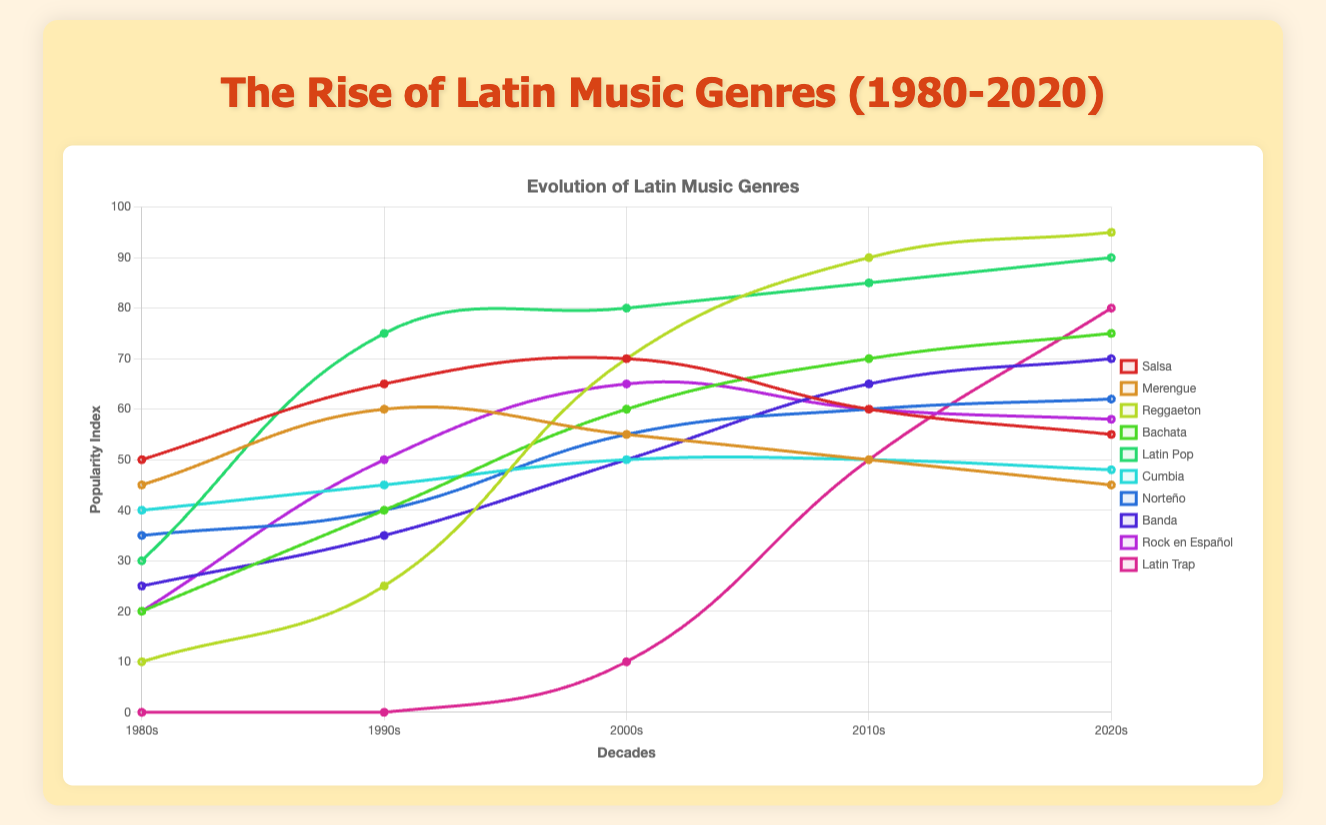What's the most popular genre in the 2020s? To find the most popular genre in the 2020s, look for the highest point on the y-axis for the 2020s decade. This is where Reggaeton has a value of 95.
Answer: Reggaeton How did the popularity of Salsa change from the 1980s to the 2020s? Locate Salsa on the chart and compare its values from the 1980s (50) and the 2020s (55). The popularity increased by 5 points.
Answer: Increased by 5 points Which genre had the greatest increase in popularity from the 1990s to the 2000s? Compare the popularity values for all genres between the 1990s and 2000s. Reggaeton increased the most, going from 25 to 70, which is an increase of 45 points.
Answer: Reggaeton Did any genre experience a decrease in popularity from one decade to the next? Check for any genres where the values drop from one decade to the next. Salsa, for example, decreases from the 2000s (70) to the 2010s (60).
Answer: Yes, Salsa What is the average popularity of Latin Pop from the 1980s to the 2020s? Sum the values of Latin Pop across all decades: 30 + 75 + 80 + 85 + 90 = 360. Then divide by the number of decades (5). 360 / 5 = 72.
Answer: 72 Did Merengue ever surpass Salsa in popularity? Compare the values of Merengue and Salsa for each decade. Merengue never surpasses Salsa in any decade.
Answer: No Which genres had a consistently upward trend over the entire period from 1980 to 2020? Look for genres where each decade's value is greater than the previous decade’s value throughout the entire period. Bachata and Banda both exhibit this consistent upward trend.
Answer: Bachata, Banda By how much did the popularity of Latin Trap change between the 2000s and the 2010s? Subtract the popularity in the 2000s (10) from its popularity in the 2010s (50) for Latin Trap. The difference is 50 - 10 = 40.
Answer: Increased by 40 Which decade saw the biggest increase in Latin Pop's popularity? Calculate the increase in popularity for Latin Pop between each consecutive decade. The biggest increase happened from the 1980s (30) to the 1990s (75), which is an increase of 45 points.
Answer: 1990s Which genres saw their highest peak in popularity during the 2010s? Compare the values for each genre during each decade to determine their peak. Reggaeton's highest value is in the 2020s (95), while Salsa's peak was in the 2000s (70). So no genres peaked in the 2010s.
Answer: None 